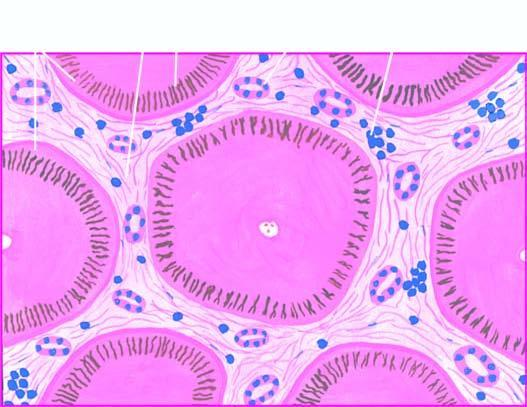do the tumour cells contain elongated bile plugs?
Answer the question using a single word or phrase. No 